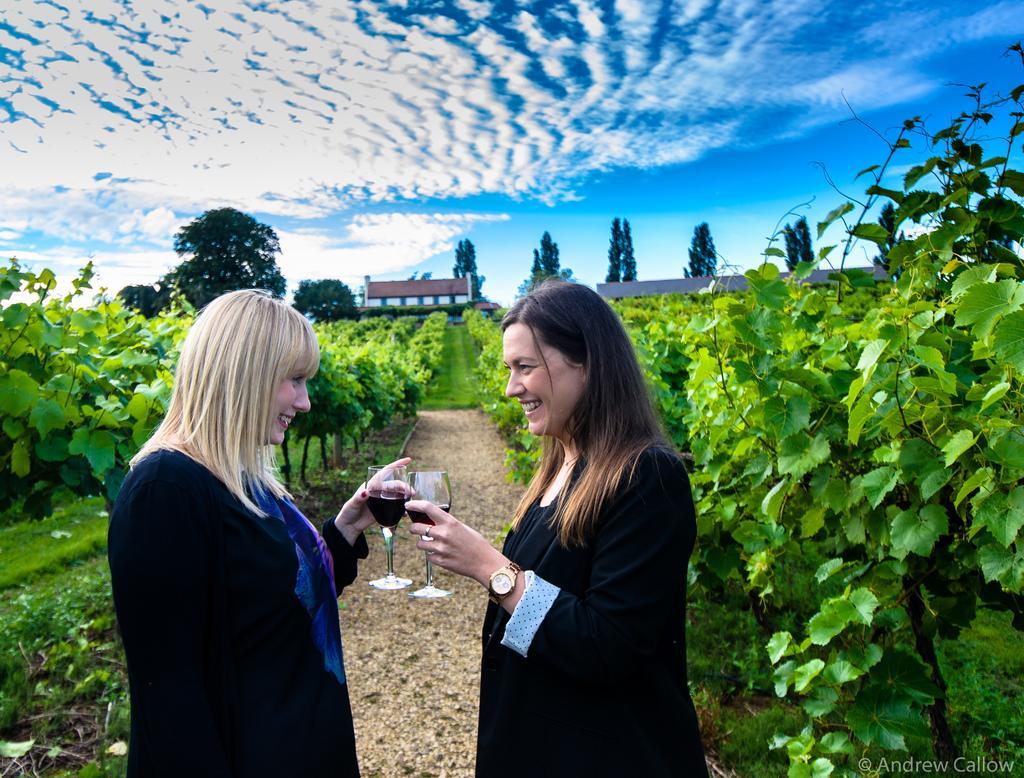Please provide a concise description of this image. In this image we can see two women holding glasses in their hands are standing on the ground. One woman is wearing a wrist watch. In the background, we can see a group of trees, plants and the cloudy sky. At the bottom we can see some text. 